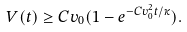Convert formula to latex. <formula><loc_0><loc_0><loc_500><loc_500>V ( t ) \geq C v _ { 0 } ( 1 - e ^ { - C v _ { 0 } ^ { 2 } t / \kappa } ) .</formula> 